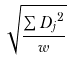<formula> <loc_0><loc_0><loc_500><loc_500>\sqrt { \frac { \sum { D _ { j } } ^ { 2 } } { w } }</formula> 